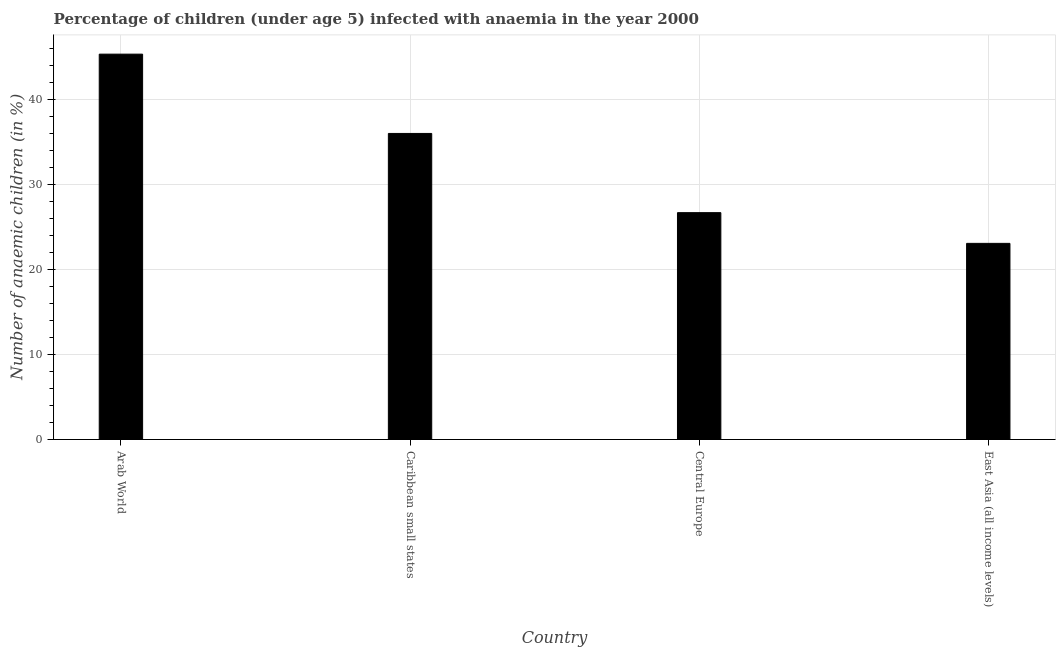Does the graph contain grids?
Offer a terse response. Yes. What is the title of the graph?
Offer a very short reply. Percentage of children (under age 5) infected with anaemia in the year 2000. What is the label or title of the X-axis?
Give a very brief answer. Country. What is the label or title of the Y-axis?
Keep it short and to the point. Number of anaemic children (in %). What is the number of anaemic children in Central Europe?
Offer a terse response. 26.7. Across all countries, what is the maximum number of anaemic children?
Your answer should be very brief. 45.36. Across all countries, what is the minimum number of anaemic children?
Ensure brevity in your answer.  23.09. In which country was the number of anaemic children maximum?
Keep it short and to the point. Arab World. In which country was the number of anaemic children minimum?
Your response must be concise. East Asia (all income levels). What is the sum of the number of anaemic children?
Your response must be concise. 131.18. What is the difference between the number of anaemic children in Arab World and East Asia (all income levels)?
Make the answer very short. 22.27. What is the average number of anaemic children per country?
Offer a terse response. 32.8. What is the median number of anaemic children?
Your answer should be compact. 31.37. In how many countries, is the number of anaemic children greater than 14 %?
Make the answer very short. 4. What is the ratio of the number of anaemic children in Arab World to that in East Asia (all income levels)?
Offer a very short reply. 1.97. Is the number of anaemic children in Arab World less than that in East Asia (all income levels)?
Ensure brevity in your answer.  No. What is the difference between the highest and the second highest number of anaemic children?
Your response must be concise. 9.33. Is the sum of the number of anaemic children in Caribbean small states and East Asia (all income levels) greater than the maximum number of anaemic children across all countries?
Your answer should be compact. Yes. What is the difference between the highest and the lowest number of anaemic children?
Provide a short and direct response. 22.27. In how many countries, is the number of anaemic children greater than the average number of anaemic children taken over all countries?
Make the answer very short. 2. Are all the bars in the graph horizontal?
Offer a very short reply. No. How many countries are there in the graph?
Your answer should be compact. 4. What is the difference between two consecutive major ticks on the Y-axis?
Ensure brevity in your answer.  10. Are the values on the major ticks of Y-axis written in scientific E-notation?
Make the answer very short. No. What is the Number of anaemic children (in %) in Arab World?
Your answer should be compact. 45.36. What is the Number of anaemic children (in %) of Caribbean small states?
Offer a very short reply. 36.03. What is the Number of anaemic children (in %) of Central Europe?
Provide a succinct answer. 26.7. What is the Number of anaemic children (in %) in East Asia (all income levels)?
Give a very brief answer. 23.09. What is the difference between the Number of anaemic children (in %) in Arab World and Caribbean small states?
Give a very brief answer. 9.33. What is the difference between the Number of anaemic children (in %) in Arab World and Central Europe?
Keep it short and to the point. 18.66. What is the difference between the Number of anaemic children (in %) in Arab World and East Asia (all income levels)?
Your answer should be very brief. 22.27. What is the difference between the Number of anaemic children (in %) in Caribbean small states and Central Europe?
Provide a short and direct response. 9.32. What is the difference between the Number of anaemic children (in %) in Caribbean small states and East Asia (all income levels)?
Provide a short and direct response. 12.94. What is the difference between the Number of anaemic children (in %) in Central Europe and East Asia (all income levels)?
Offer a very short reply. 3.62. What is the ratio of the Number of anaemic children (in %) in Arab World to that in Caribbean small states?
Your answer should be compact. 1.26. What is the ratio of the Number of anaemic children (in %) in Arab World to that in Central Europe?
Ensure brevity in your answer.  1.7. What is the ratio of the Number of anaemic children (in %) in Arab World to that in East Asia (all income levels)?
Provide a succinct answer. 1.97. What is the ratio of the Number of anaemic children (in %) in Caribbean small states to that in Central Europe?
Give a very brief answer. 1.35. What is the ratio of the Number of anaemic children (in %) in Caribbean small states to that in East Asia (all income levels)?
Offer a very short reply. 1.56. What is the ratio of the Number of anaemic children (in %) in Central Europe to that in East Asia (all income levels)?
Offer a terse response. 1.16. 